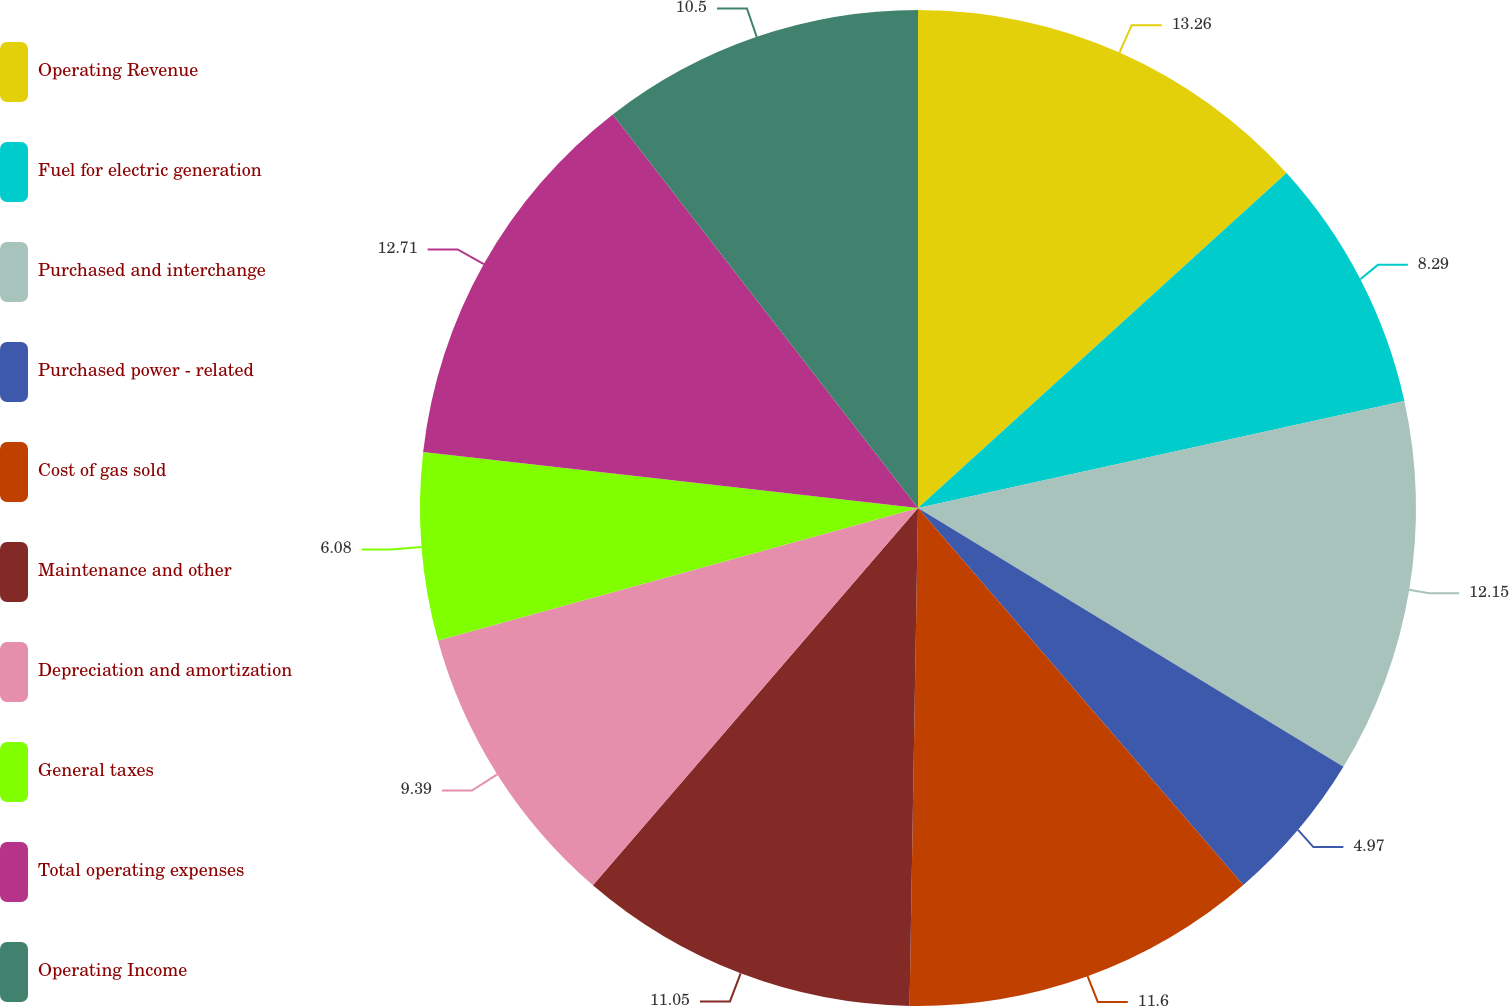Convert chart. <chart><loc_0><loc_0><loc_500><loc_500><pie_chart><fcel>Operating Revenue<fcel>Fuel for electric generation<fcel>Purchased and interchange<fcel>Purchased power - related<fcel>Cost of gas sold<fcel>Maintenance and other<fcel>Depreciation and amortization<fcel>General taxes<fcel>Total operating expenses<fcel>Operating Income<nl><fcel>13.26%<fcel>8.29%<fcel>12.15%<fcel>4.97%<fcel>11.6%<fcel>11.05%<fcel>9.39%<fcel>6.08%<fcel>12.71%<fcel>10.5%<nl></chart> 